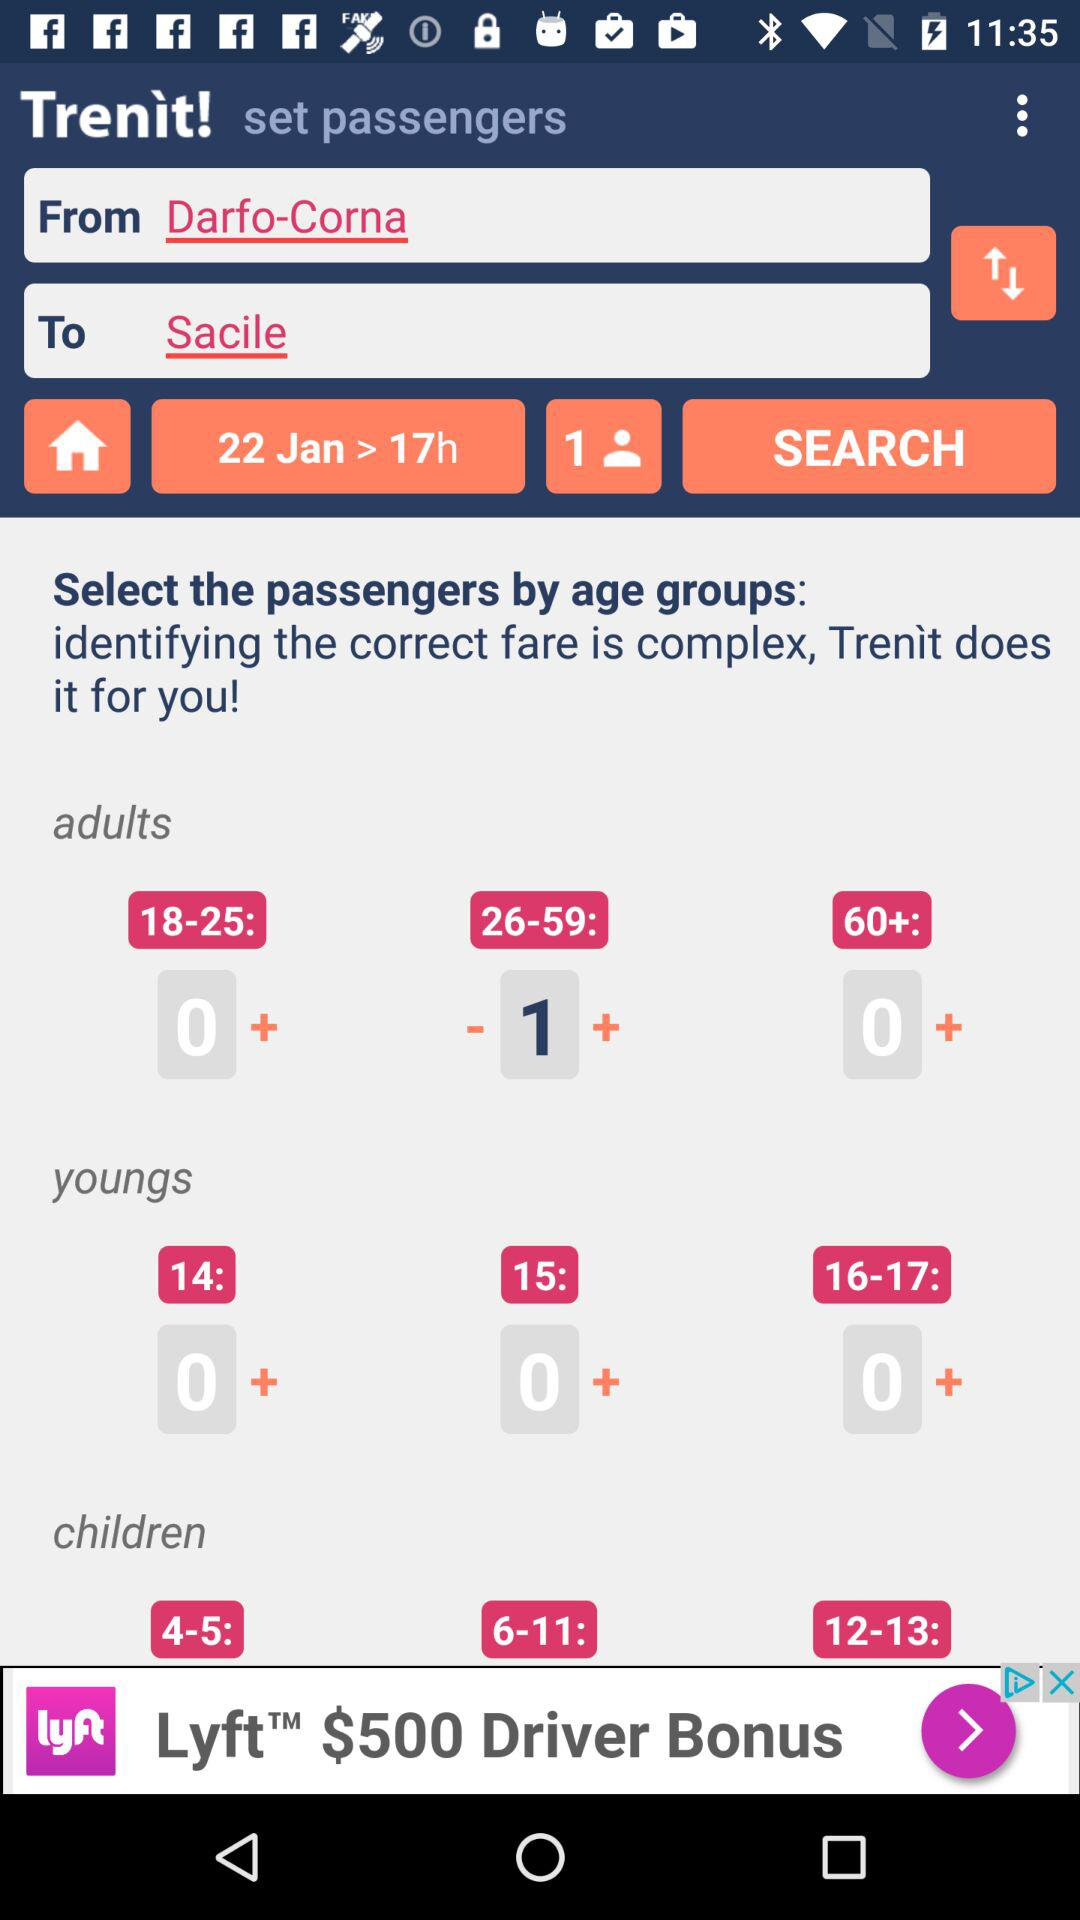From which station does the train start? The train starts from Darfo-Corna. 